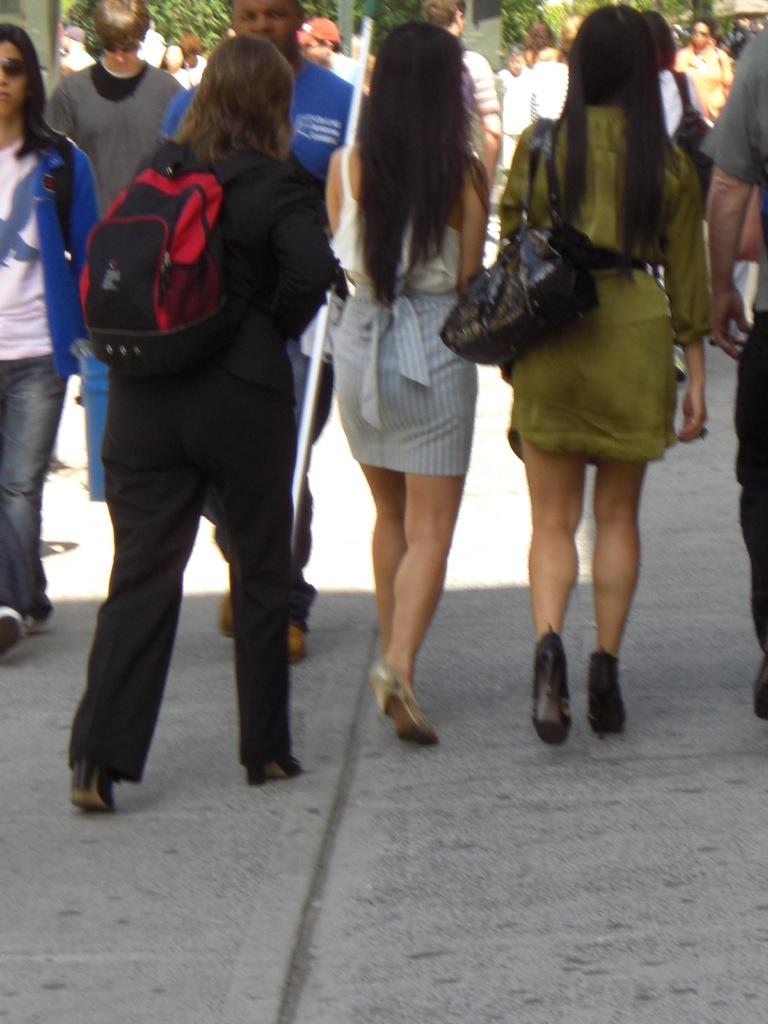What are the people in the image doing? The people in the image are walking on a path. What are the women carrying in the image? The two women are wearing bags. What can be seen in the background of the image? There are plants visible in the background of the image. What is the thumb's role in the image? There is no thumb present in the image, so it does not have a role. 